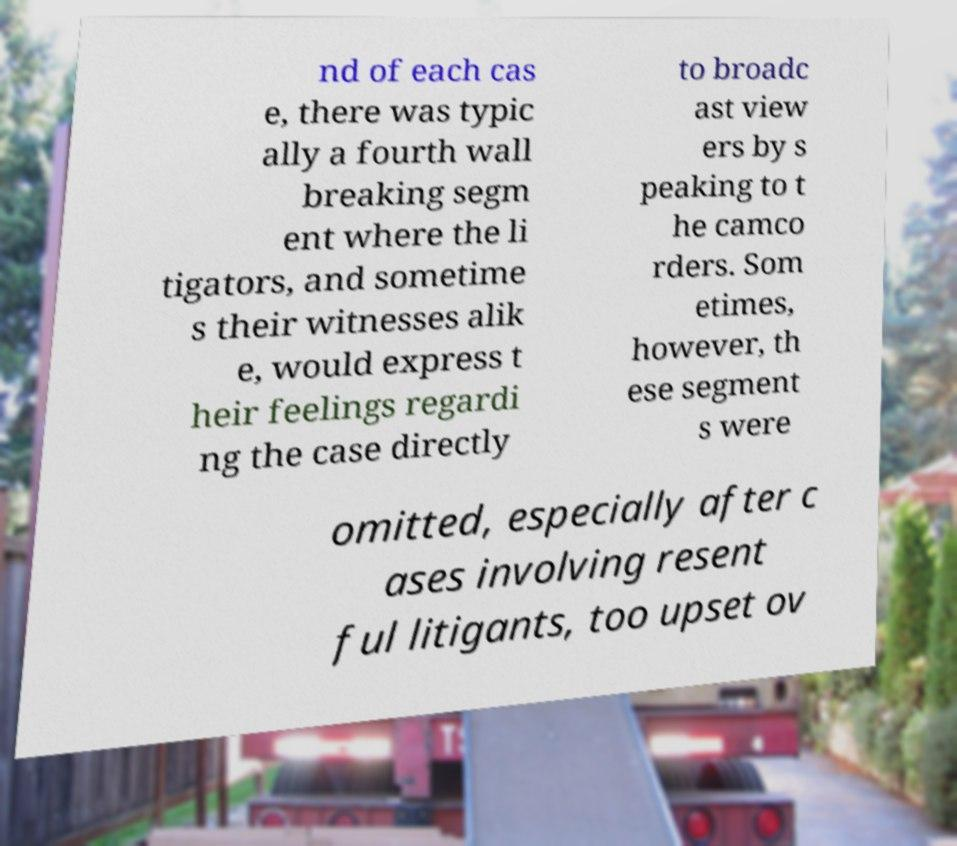I need the written content from this picture converted into text. Can you do that? nd of each cas e, there was typic ally a fourth wall breaking segm ent where the li tigators, and sometime s their witnesses alik e, would express t heir feelings regardi ng the case directly to broadc ast view ers by s peaking to t he camco rders. Som etimes, however, th ese segment s were omitted, especially after c ases involving resent ful litigants, too upset ov 